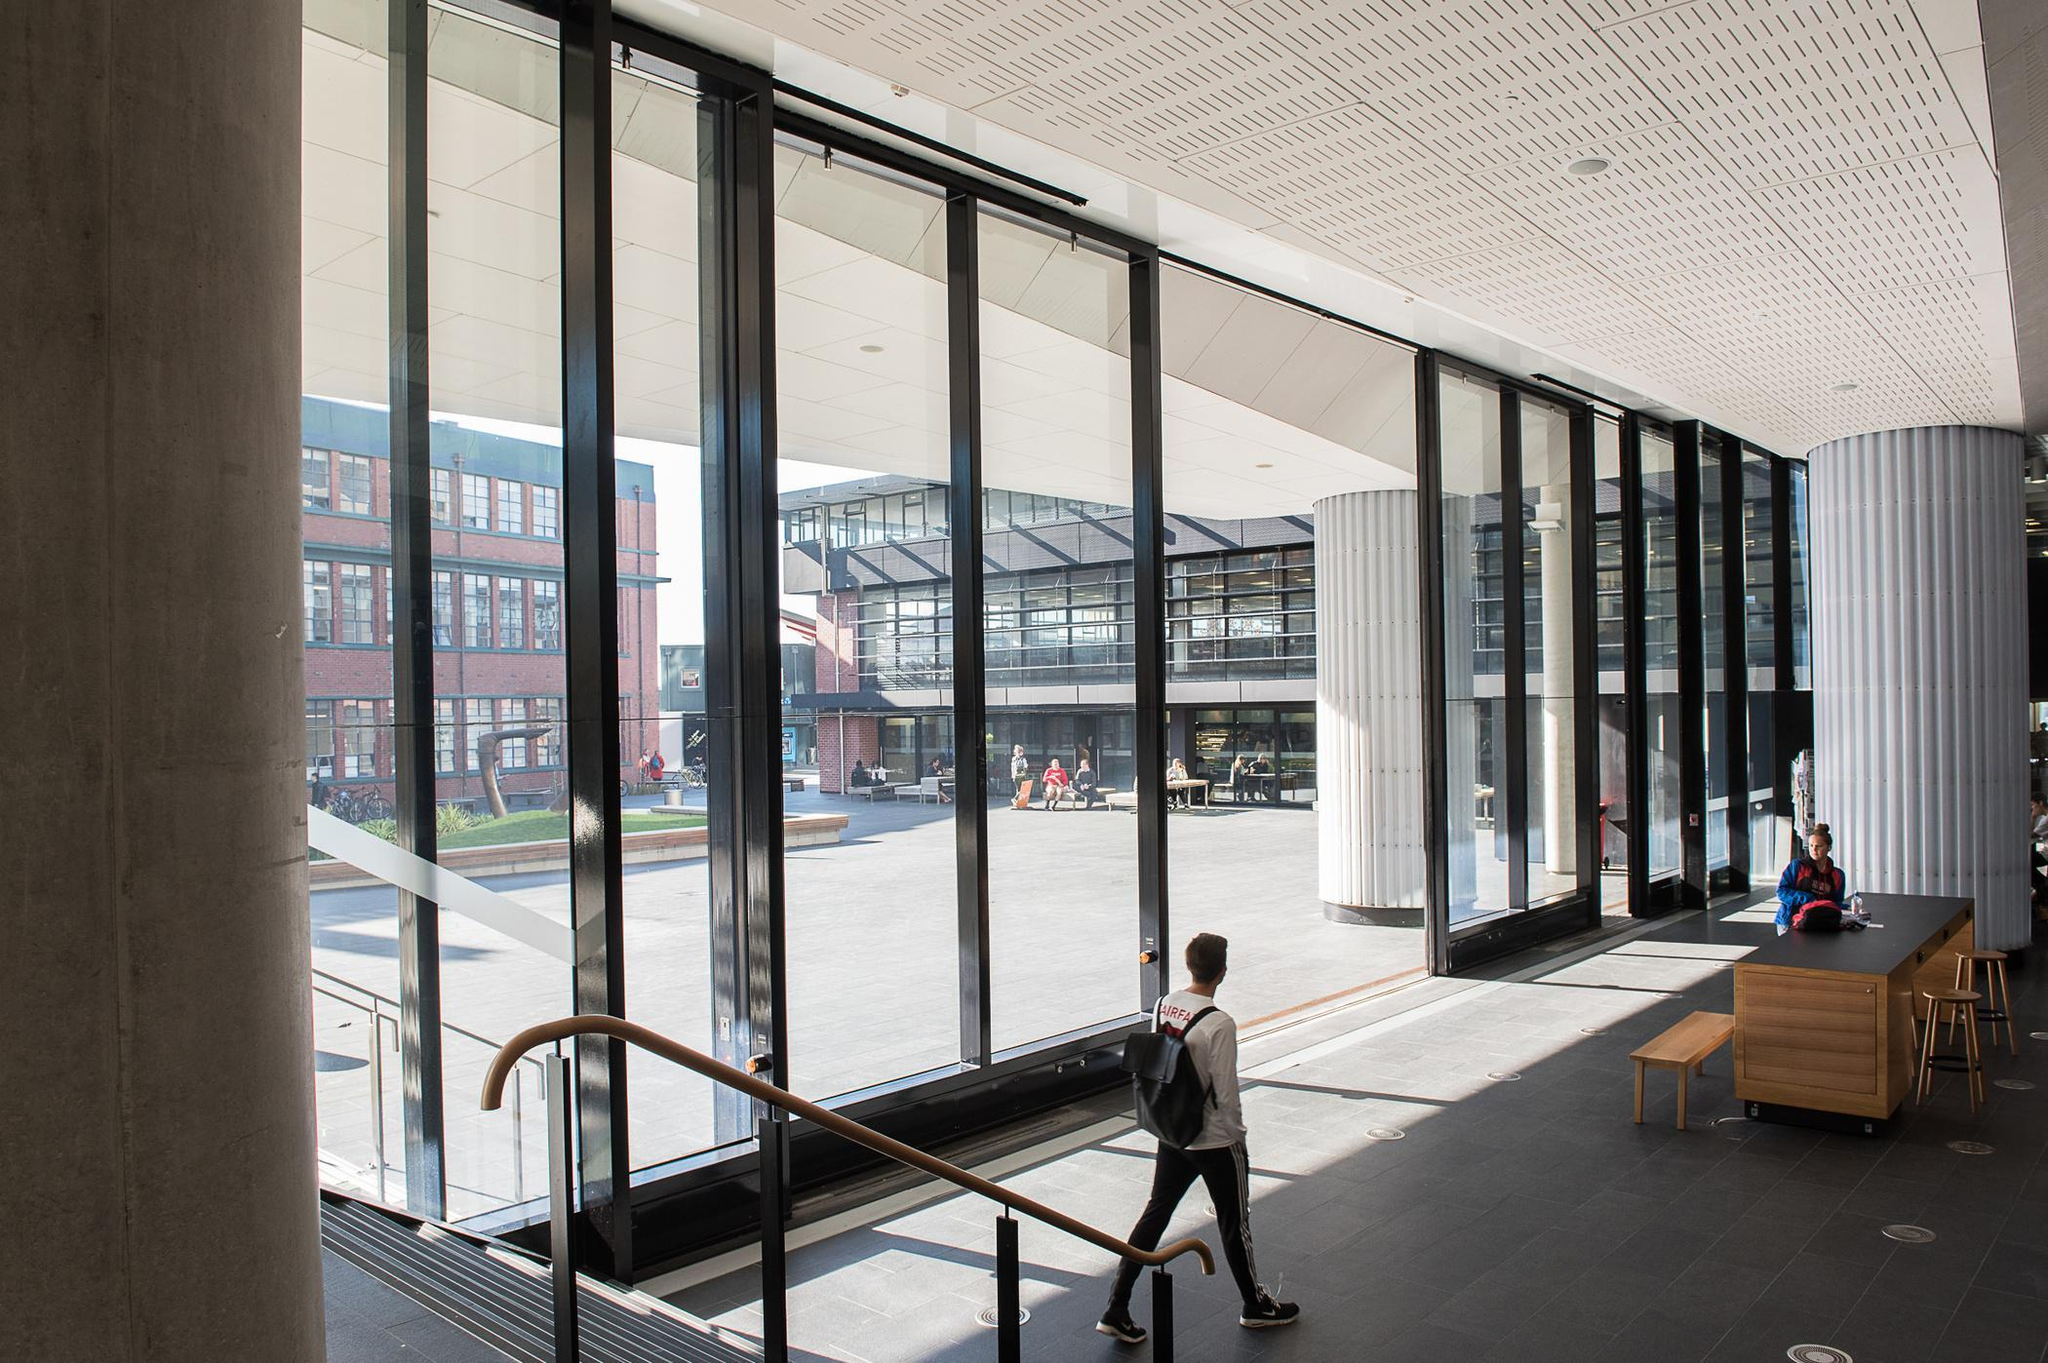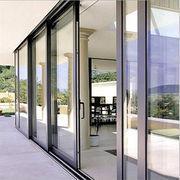The first image is the image on the left, the second image is the image on the right. Evaluate the accuracy of this statement regarding the images: "The right image shows columns wth cap tops next to a wall of sliding glass doors and glass windows.". Is it true? Answer yes or no. Yes. The first image is the image on the left, the second image is the image on the right. Assess this claim about the two images: "Doors are open in both images.". Correct or not? Answer yes or no. Yes. 